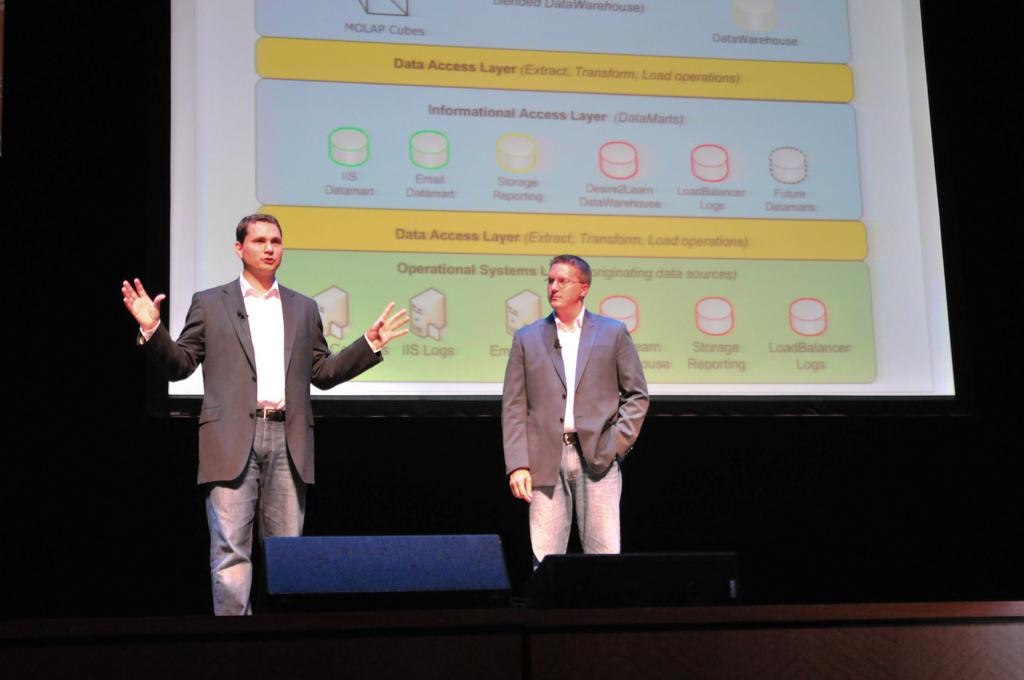How many people are present in the image? There are two people standing in the image. What are the people wearing? The people are wearing suits. What objects can be seen at the bottom of the image? There are speakers at the bottom of the image. What is visible in the background of the image? There is a screen in the background of the image. Are there any trees visible in the image? No, there are no trees present in the image. Can you see any mist in the image? No, there is no mist visible in the image. 